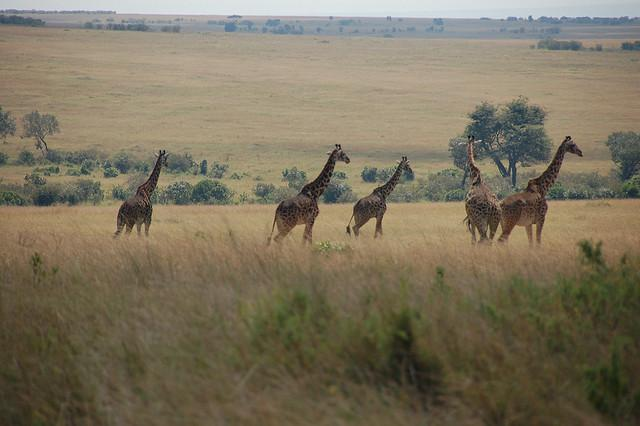Which giraffe is farthest from this small herd? left giraffe 